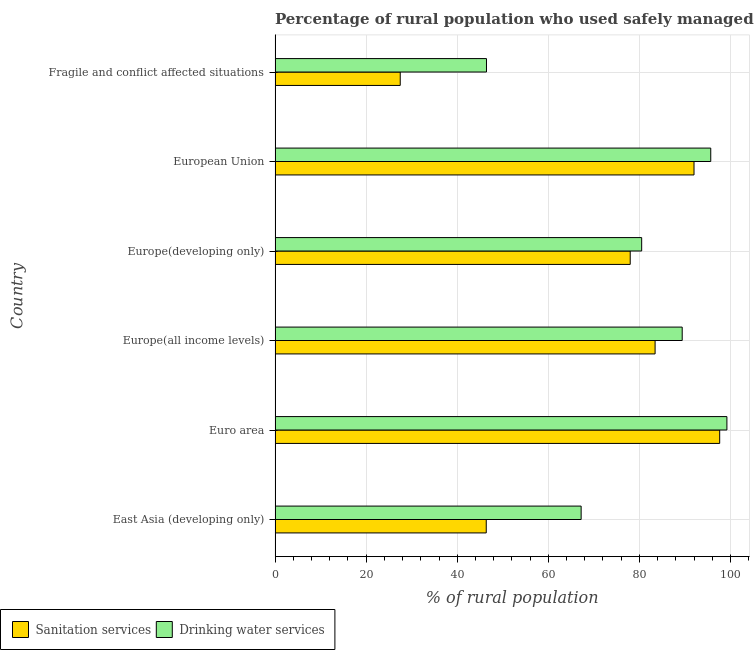How many different coloured bars are there?
Your answer should be very brief. 2. How many groups of bars are there?
Give a very brief answer. 6. What is the label of the 4th group of bars from the top?
Keep it short and to the point. Europe(all income levels). In how many cases, is the number of bars for a given country not equal to the number of legend labels?
Keep it short and to the point. 0. What is the percentage of rural population who used drinking water services in Fragile and conflict affected situations?
Make the answer very short. 46.42. Across all countries, what is the maximum percentage of rural population who used drinking water services?
Make the answer very short. 99.22. Across all countries, what is the minimum percentage of rural population who used drinking water services?
Provide a succinct answer. 46.42. In which country was the percentage of rural population who used drinking water services minimum?
Ensure brevity in your answer.  Fragile and conflict affected situations. What is the total percentage of rural population who used drinking water services in the graph?
Provide a succinct answer. 478.41. What is the difference between the percentage of rural population who used sanitation services in European Union and that in Fragile and conflict affected situations?
Keep it short and to the point. 64.51. What is the difference between the percentage of rural population who used drinking water services in Euro area and the percentage of rural population who used sanitation services in Fragile and conflict affected situations?
Provide a short and direct response. 71.73. What is the average percentage of rural population who used sanitation services per country?
Offer a terse response. 70.82. What is the difference between the percentage of rural population who used sanitation services and percentage of rural population who used drinking water services in East Asia (developing only)?
Ensure brevity in your answer.  -20.84. In how many countries, is the percentage of rural population who used drinking water services greater than 36 %?
Give a very brief answer. 6. What is the ratio of the percentage of rural population who used sanitation services in East Asia (developing only) to that in Europe(developing only)?
Your response must be concise. 0.59. Is the percentage of rural population who used sanitation services in Euro area less than that in Europe(all income levels)?
Give a very brief answer. No. Is the difference between the percentage of rural population who used drinking water services in Euro area and Fragile and conflict affected situations greater than the difference between the percentage of rural population who used sanitation services in Euro area and Fragile and conflict affected situations?
Your answer should be compact. No. What is the difference between the highest and the second highest percentage of rural population who used drinking water services?
Offer a very short reply. 3.55. What is the difference between the highest and the lowest percentage of rural population who used sanitation services?
Ensure brevity in your answer.  70.15. What does the 2nd bar from the top in Europe(all income levels) represents?
Offer a terse response. Sanitation services. What does the 2nd bar from the bottom in Euro area represents?
Ensure brevity in your answer.  Drinking water services. Are all the bars in the graph horizontal?
Make the answer very short. Yes. How many countries are there in the graph?
Your response must be concise. 6. Does the graph contain any zero values?
Keep it short and to the point. No. Does the graph contain grids?
Give a very brief answer. Yes. Where does the legend appear in the graph?
Make the answer very short. Bottom left. How many legend labels are there?
Offer a very short reply. 2. What is the title of the graph?
Offer a terse response. Percentage of rural population who used safely managed services in 1997. Does "Resident workers" appear as one of the legend labels in the graph?
Give a very brief answer. No. What is the label or title of the X-axis?
Your answer should be compact. % of rural population. What is the label or title of the Y-axis?
Your answer should be compact. Country. What is the % of rural population of Sanitation services in East Asia (developing only)?
Offer a very short reply. 46.37. What is the % of rural population in Drinking water services in East Asia (developing only)?
Provide a short and direct response. 67.21. What is the % of rural population in Sanitation services in Euro area?
Provide a succinct answer. 97.63. What is the % of rural population in Drinking water services in Euro area?
Your answer should be compact. 99.22. What is the % of rural population in Sanitation services in Europe(all income levels)?
Offer a very short reply. 83.45. What is the % of rural population in Drinking water services in Europe(all income levels)?
Keep it short and to the point. 89.4. What is the % of rural population in Sanitation services in Europe(developing only)?
Your answer should be compact. 77.99. What is the % of rural population in Drinking water services in Europe(developing only)?
Provide a short and direct response. 80.5. What is the % of rural population in Sanitation services in European Union?
Ensure brevity in your answer.  91.99. What is the % of rural population of Drinking water services in European Union?
Ensure brevity in your answer.  95.67. What is the % of rural population of Sanitation services in Fragile and conflict affected situations?
Your response must be concise. 27.48. What is the % of rural population of Drinking water services in Fragile and conflict affected situations?
Keep it short and to the point. 46.42. Across all countries, what is the maximum % of rural population in Sanitation services?
Provide a succinct answer. 97.63. Across all countries, what is the maximum % of rural population in Drinking water services?
Your answer should be compact. 99.22. Across all countries, what is the minimum % of rural population in Sanitation services?
Provide a succinct answer. 27.48. Across all countries, what is the minimum % of rural population in Drinking water services?
Offer a very short reply. 46.42. What is the total % of rural population of Sanitation services in the graph?
Your answer should be compact. 424.91. What is the total % of rural population in Drinking water services in the graph?
Your answer should be very brief. 478.41. What is the difference between the % of rural population of Sanitation services in East Asia (developing only) and that in Euro area?
Your response must be concise. -51.26. What is the difference between the % of rural population in Drinking water services in East Asia (developing only) and that in Euro area?
Provide a short and direct response. -32.01. What is the difference between the % of rural population of Sanitation services in East Asia (developing only) and that in Europe(all income levels)?
Ensure brevity in your answer.  -37.08. What is the difference between the % of rural population of Drinking water services in East Asia (developing only) and that in Europe(all income levels)?
Ensure brevity in your answer.  -22.19. What is the difference between the % of rural population of Sanitation services in East Asia (developing only) and that in Europe(developing only)?
Give a very brief answer. -31.61. What is the difference between the % of rural population in Drinking water services in East Asia (developing only) and that in Europe(developing only)?
Keep it short and to the point. -13.29. What is the difference between the % of rural population of Sanitation services in East Asia (developing only) and that in European Union?
Your answer should be compact. -45.62. What is the difference between the % of rural population of Drinking water services in East Asia (developing only) and that in European Union?
Your answer should be compact. -28.46. What is the difference between the % of rural population in Sanitation services in East Asia (developing only) and that in Fragile and conflict affected situations?
Your answer should be compact. 18.89. What is the difference between the % of rural population of Drinking water services in East Asia (developing only) and that in Fragile and conflict affected situations?
Make the answer very short. 20.79. What is the difference between the % of rural population in Sanitation services in Euro area and that in Europe(all income levels)?
Provide a succinct answer. 14.18. What is the difference between the % of rural population in Drinking water services in Euro area and that in Europe(all income levels)?
Keep it short and to the point. 9.81. What is the difference between the % of rural population in Sanitation services in Euro area and that in Europe(developing only)?
Your answer should be very brief. 19.65. What is the difference between the % of rural population in Drinking water services in Euro area and that in Europe(developing only)?
Ensure brevity in your answer.  18.71. What is the difference between the % of rural population of Sanitation services in Euro area and that in European Union?
Give a very brief answer. 5.64. What is the difference between the % of rural population in Drinking water services in Euro area and that in European Union?
Your answer should be very brief. 3.55. What is the difference between the % of rural population in Sanitation services in Euro area and that in Fragile and conflict affected situations?
Your answer should be very brief. 70.15. What is the difference between the % of rural population of Drinking water services in Euro area and that in Fragile and conflict affected situations?
Provide a succinct answer. 52.79. What is the difference between the % of rural population of Sanitation services in Europe(all income levels) and that in Europe(developing only)?
Your answer should be compact. 5.46. What is the difference between the % of rural population of Drinking water services in Europe(all income levels) and that in Europe(developing only)?
Make the answer very short. 8.9. What is the difference between the % of rural population in Sanitation services in Europe(all income levels) and that in European Union?
Your answer should be compact. -8.55. What is the difference between the % of rural population in Drinking water services in Europe(all income levels) and that in European Union?
Provide a succinct answer. -6.27. What is the difference between the % of rural population of Sanitation services in Europe(all income levels) and that in Fragile and conflict affected situations?
Provide a succinct answer. 55.96. What is the difference between the % of rural population in Drinking water services in Europe(all income levels) and that in Fragile and conflict affected situations?
Your response must be concise. 42.98. What is the difference between the % of rural population in Sanitation services in Europe(developing only) and that in European Union?
Offer a very short reply. -14.01. What is the difference between the % of rural population of Drinking water services in Europe(developing only) and that in European Union?
Make the answer very short. -15.17. What is the difference between the % of rural population in Sanitation services in Europe(developing only) and that in Fragile and conflict affected situations?
Provide a succinct answer. 50.5. What is the difference between the % of rural population of Drinking water services in Europe(developing only) and that in Fragile and conflict affected situations?
Ensure brevity in your answer.  34.08. What is the difference between the % of rural population of Sanitation services in European Union and that in Fragile and conflict affected situations?
Give a very brief answer. 64.51. What is the difference between the % of rural population of Drinking water services in European Union and that in Fragile and conflict affected situations?
Offer a terse response. 49.25. What is the difference between the % of rural population in Sanitation services in East Asia (developing only) and the % of rural population in Drinking water services in Euro area?
Give a very brief answer. -52.84. What is the difference between the % of rural population in Sanitation services in East Asia (developing only) and the % of rural population in Drinking water services in Europe(all income levels)?
Keep it short and to the point. -43.03. What is the difference between the % of rural population of Sanitation services in East Asia (developing only) and the % of rural population of Drinking water services in Europe(developing only)?
Your answer should be very brief. -34.13. What is the difference between the % of rural population in Sanitation services in East Asia (developing only) and the % of rural population in Drinking water services in European Union?
Provide a succinct answer. -49.3. What is the difference between the % of rural population of Sanitation services in East Asia (developing only) and the % of rural population of Drinking water services in Fragile and conflict affected situations?
Provide a short and direct response. -0.05. What is the difference between the % of rural population in Sanitation services in Euro area and the % of rural population in Drinking water services in Europe(all income levels)?
Offer a very short reply. 8.23. What is the difference between the % of rural population of Sanitation services in Euro area and the % of rural population of Drinking water services in Europe(developing only)?
Keep it short and to the point. 17.13. What is the difference between the % of rural population of Sanitation services in Euro area and the % of rural population of Drinking water services in European Union?
Your response must be concise. 1.96. What is the difference between the % of rural population of Sanitation services in Euro area and the % of rural population of Drinking water services in Fragile and conflict affected situations?
Give a very brief answer. 51.21. What is the difference between the % of rural population in Sanitation services in Europe(all income levels) and the % of rural population in Drinking water services in Europe(developing only)?
Keep it short and to the point. 2.95. What is the difference between the % of rural population of Sanitation services in Europe(all income levels) and the % of rural population of Drinking water services in European Union?
Make the answer very short. -12.22. What is the difference between the % of rural population of Sanitation services in Europe(all income levels) and the % of rural population of Drinking water services in Fragile and conflict affected situations?
Offer a very short reply. 37.03. What is the difference between the % of rural population in Sanitation services in Europe(developing only) and the % of rural population in Drinking water services in European Union?
Give a very brief answer. -17.68. What is the difference between the % of rural population of Sanitation services in Europe(developing only) and the % of rural population of Drinking water services in Fragile and conflict affected situations?
Provide a short and direct response. 31.56. What is the difference between the % of rural population of Sanitation services in European Union and the % of rural population of Drinking water services in Fragile and conflict affected situations?
Provide a short and direct response. 45.57. What is the average % of rural population in Sanitation services per country?
Make the answer very short. 70.82. What is the average % of rural population of Drinking water services per country?
Make the answer very short. 79.74. What is the difference between the % of rural population of Sanitation services and % of rural population of Drinking water services in East Asia (developing only)?
Your answer should be very brief. -20.84. What is the difference between the % of rural population in Sanitation services and % of rural population in Drinking water services in Euro area?
Ensure brevity in your answer.  -1.58. What is the difference between the % of rural population of Sanitation services and % of rural population of Drinking water services in Europe(all income levels)?
Provide a short and direct response. -5.95. What is the difference between the % of rural population of Sanitation services and % of rural population of Drinking water services in Europe(developing only)?
Make the answer very short. -2.52. What is the difference between the % of rural population of Sanitation services and % of rural population of Drinking water services in European Union?
Provide a short and direct response. -3.67. What is the difference between the % of rural population in Sanitation services and % of rural population in Drinking water services in Fragile and conflict affected situations?
Make the answer very short. -18.94. What is the ratio of the % of rural population in Sanitation services in East Asia (developing only) to that in Euro area?
Your response must be concise. 0.47. What is the ratio of the % of rural population of Drinking water services in East Asia (developing only) to that in Euro area?
Your answer should be very brief. 0.68. What is the ratio of the % of rural population in Sanitation services in East Asia (developing only) to that in Europe(all income levels)?
Ensure brevity in your answer.  0.56. What is the ratio of the % of rural population in Drinking water services in East Asia (developing only) to that in Europe(all income levels)?
Keep it short and to the point. 0.75. What is the ratio of the % of rural population of Sanitation services in East Asia (developing only) to that in Europe(developing only)?
Offer a very short reply. 0.59. What is the ratio of the % of rural population in Drinking water services in East Asia (developing only) to that in Europe(developing only)?
Provide a short and direct response. 0.83. What is the ratio of the % of rural population in Sanitation services in East Asia (developing only) to that in European Union?
Keep it short and to the point. 0.5. What is the ratio of the % of rural population in Drinking water services in East Asia (developing only) to that in European Union?
Offer a terse response. 0.7. What is the ratio of the % of rural population in Sanitation services in East Asia (developing only) to that in Fragile and conflict affected situations?
Your answer should be very brief. 1.69. What is the ratio of the % of rural population of Drinking water services in East Asia (developing only) to that in Fragile and conflict affected situations?
Provide a succinct answer. 1.45. What is the ratio of the % of rural population of Sanitation services in Euro area to that in Europe(all income levels)?
Your answer should be compact. 1.17. What is the ratio of the % of rural population of Drinking water services in Euro area to that in Europe(all income levels)?
Make the answer very short. 1.11. What is the ratio of the % of rural population in Sanitation services in Euro area to that in Europe(developing only)?
Your answer should be compact. 1.25. What is the ratio of the % of rural population in Drinking water services in Euro area to that in Europe(developing only)?
Provide a succinct answer. 1.23. What is the ratio of the % of rural population of Sanitation services in Euro area to that in European Union?
Make the answer very short. 1.06. What is the ratio of the % of rural population in Drinking water services in Euro area to that in European Union?
Offer a very short reply. 1.04. What is the ratio of the % of rural population of Sanitation services in Euro area to that in Fragile and conflict affected situations?
Offer a terse response. 3.55. What is the ratio of the % of rural population of Drinking water services in Euro area to that in Fragile and conflict affected situations?
Your answer should be compact. 2.14. What is the ratio of the % of rural population in Sanitation services in Europe(all income levels) to that in Europe(developing only)?
Keep it short and to the point. 1.07. What is the ratio of the % of rural population of Drinking water services in Europe(all income levels) to that in Europe(developing only)?
Offer a terse response. 1.11. What is the ratio of the % of rural population in Sanitation services in Europe(all income levels) to that in European Union?
Provide a succinct answer. 0.91. What is the ratio of the % of rural population in Drinking water services in Europe(all income levels) to that in European Union?
Your answer should be very brief. 0.93. What is the ratio of the % of rural population in Sanitation services in Europe(all income levels) to that in Fragile and conflict affected situations?
Your answer should be compact. 3.04. What is the ratio of the % of rural population of Drinking water services in Europe(all income levels) to that in Fragile and conflict affected situations?
Offer a very short reply. 1.93. What is the ratio of the % of rural population of Sanitation services in Europe(developing only) to that in European Union?
Keep it short and to the point. 0.85. What is the ratio of the % of rural population in Drinking water services in Europe(developing only) to that in European Union?
Your answer should be compact. 0.84. What is the ratio of the % of rural population in Sanitation services in Europe(developing only) to that in Fragile and conflict affected situations?
Ensure brevity in your answer.  2.84. What is the ratio of the % of rural population in Drinking water services in Europe(developing only) to that in Fragile and conflict affected situations?
Keep it short and to the point. 1.73. What is the ratio of the % of rural population of Sanitation services in European Union to that in Fragile and conflict affected situations?
Keep it short and to the point. 3.35. What is the ratio of the % of rural population of Drinking water services in European Union to that in Fragile and conflict affected situations?
Offer a very short reply. 2.06. What is the difference between the highest and the second highest % of rural population in Sanitation services?
Offer a terse response. 5.64. What is the difference between the highest and the second highest % of rural population in Drinking water services?
Offer a very short reply. 3.55. What is the difference between the highest and the lowest % of rural population of Sanitation services?
Offer a terse response. 70.15. What is the difference between the highest and the lowest % of rural population in Drinking water services?
Offer a terse response. 52.79. 